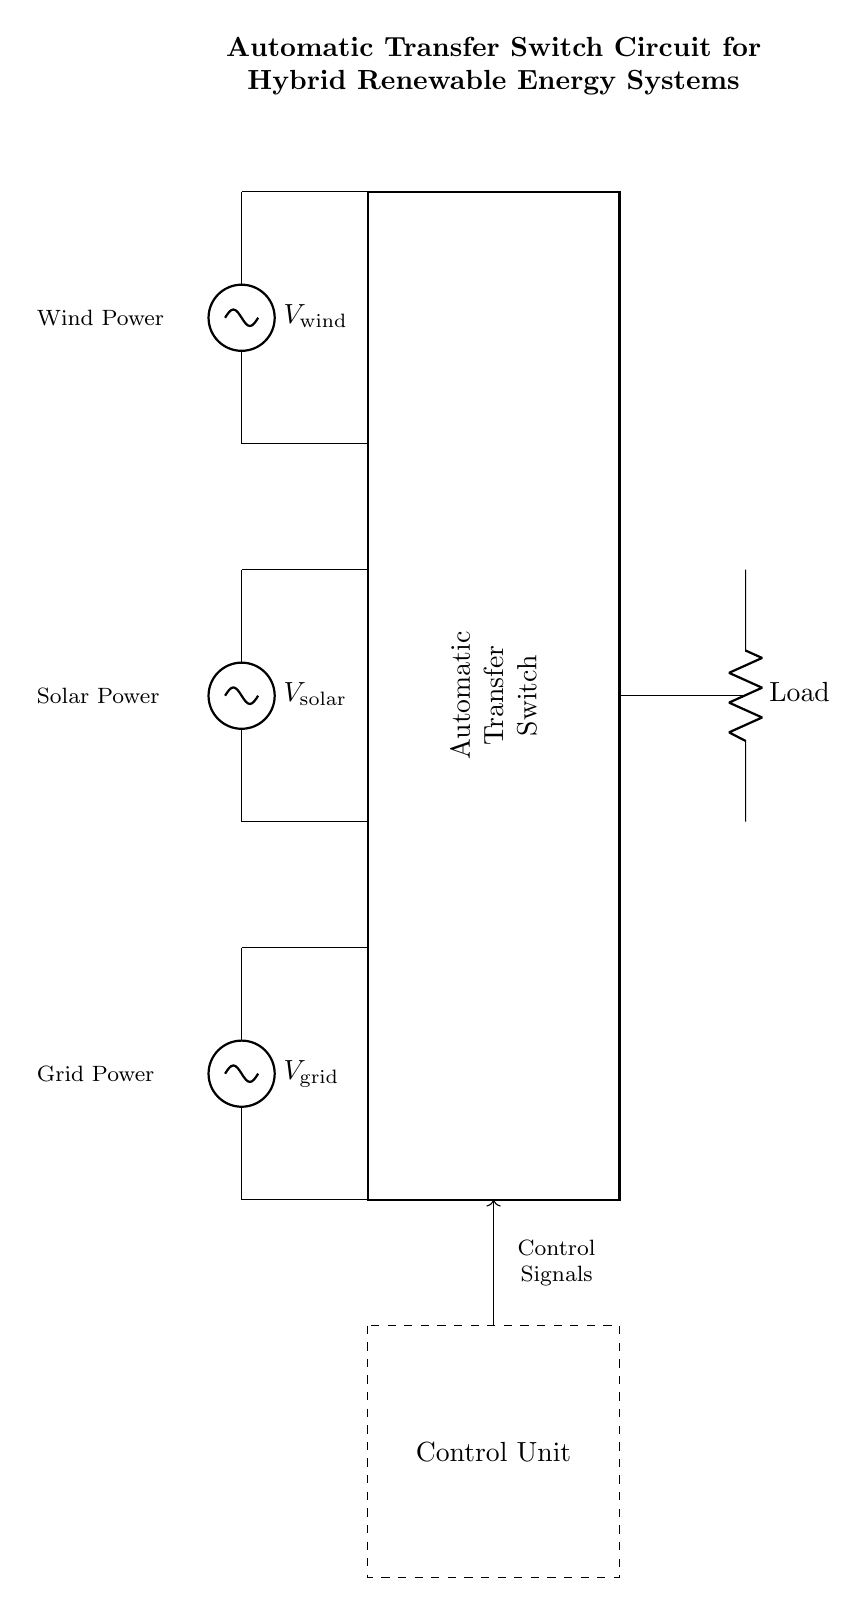What types of renewable energy sources are depicted in this circuit? The circuit diagram shows three renewable energy sources: solar, wind, and grid power. Each source is denoted with a unique voltage symbol and labeled accordingly.
Answer: solar, wind, grid power What does the rectangle represent in the circuit? The rectangle in the diagram represents the Automatic Transfer Switch, which is the key component that manages the switching between different power sources. It is labeled clearly, showing its function in the circuit.
Answer: Automatic Transfer Switch How many power sources are connected to the Automatic Transfer Switch? There are three power sources connected to the Automatic Transfer Switch: one for solar power, one for wind power, and one for grid power. Each source leads to the switch, indicating their connection.
Answer: three What type of load is shown in the circuit? The circuit shows a resistive load, represented by the resistor symbol labeled as "Load." This indicates that the energy generated by the sources is ultimately used to power a resistive device.
Answer: Load What is the purpose of the Control Unit in this circuit? The Control Unit manages the operation of the Automatic Transfer Switch by sending control signals. It ensures that the switch operates correctly based on the availability of power from the renewable sources.
Answer: Manage operation Explain the relationship between the Control Unit and the Automatic Transfer Switch. The Control Unit is responsible for monitoring the status of the different power sources and sends control signals to the Automatic Transfer Switch. This allows the switch to connect the load to the most appropriate power source depending on their availability, ensuring optimal operation of the hybrid system.
Answer: Control signals manage switching 